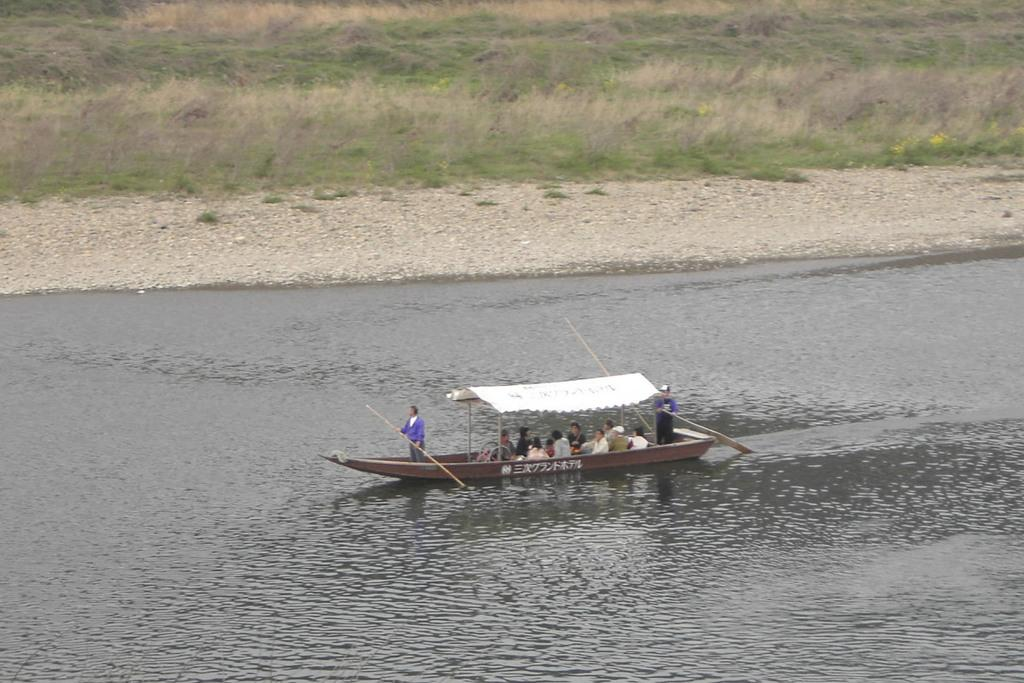What can be seen on the water in the image? There is a boat visible on the lake in the image. What are the people on the boat doing? There are people sitting on the boat, and two of them are holding sticks. What is the natural setting visible in the image? Grass is visible at the top of the image. What type of noise can be heard coming from the library in the image? There is no library present in the image, so it's not possible to determine what type of noise might be heard. 